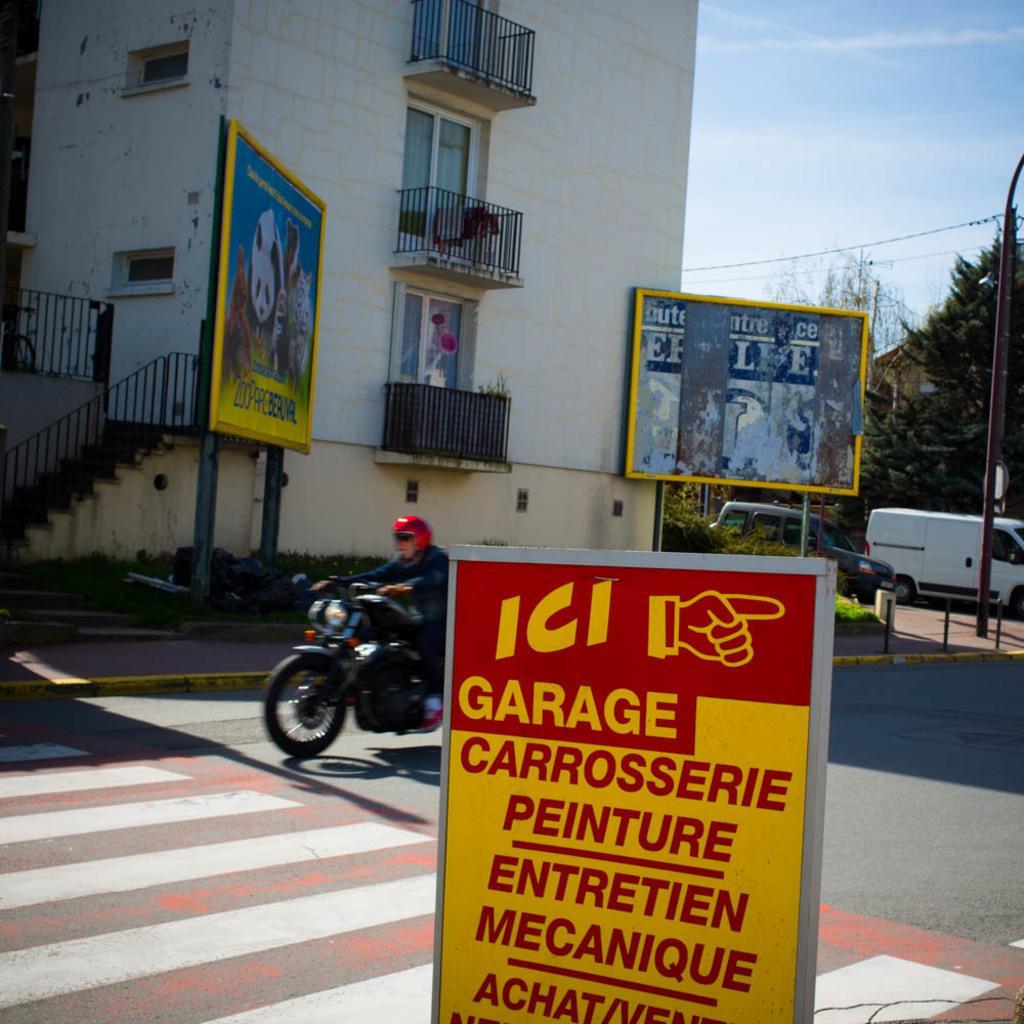In one or two sentences, can you explain what this image depicts? In the center of the image we can see a man riding bike. At the bottom there is a board. In the background there are hoardings, pole, cars, trees, building and sky. 